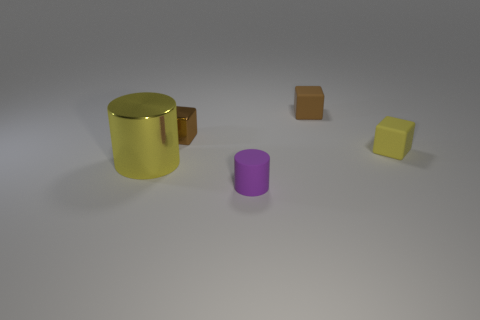There is a rubber thing behind the yellow cube; does it have the same color as the tiny metallic block?
Provide a short and direct response. Yes. What is the shape of the tiny brown metal thing behind the small rubber cube that is in front of the small metallic object?
Your answer should be very brief. Cube. Are there fewer small cubes in front of the big metallic thing than rubber blocks that are on the left side of the yellow cube?
Ensure brevity in your answer.  Yes. What size is the other object that is the same shape as the small purple rubber thing?
Ensure brevity in your answer.  Large. Is there any other thing that has the same size as the yellow cylinder?
Offer a very short reply. No. What number of objects are either rubber objects right of the small cylinder or blocks that are on the right side of the purple matte object?
Ensure brevity in your answer.  2. Do the purple rubber thing and the metallic cylinder have the same size?
Ensure brevity in your answer.  No. Are there more matte cylinders than big brown shiny balls?
Ensure brevity in your answer.  Yes. What number of other things are there of the same color as the tiny cylinder?
Ensure brevity in your answer.  0. How many objects are either brown rubber blocks or tiny cyan matte cylinders?
Provide a succinct answer. 1. 